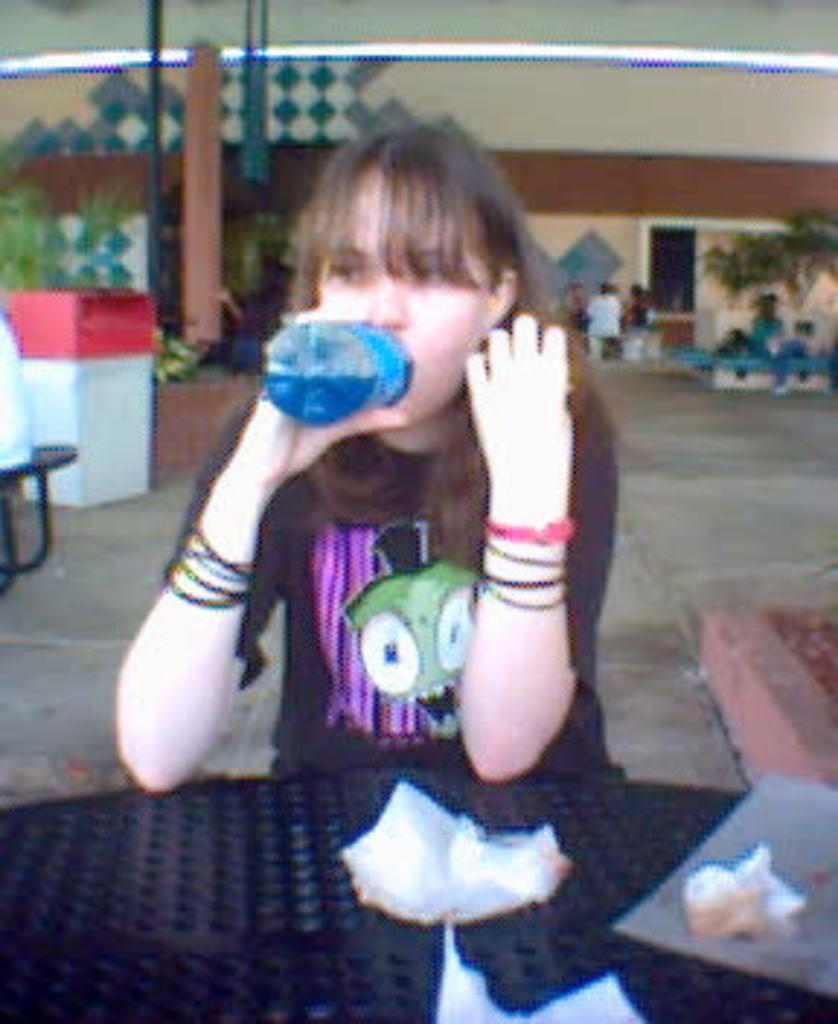Who is present in the image? There is a woman in the image. What is the woman doing in the image? The woman is sitting at a table. What is the woman holding in her hand? The woman is holding a bottle in her hand. What is the woman doing with the bottle? The woman is drinking from the bottle. What language is the woman speaking in the image? There is no indication of the woman speaking in the image, so it cannot be determined from the picture. 